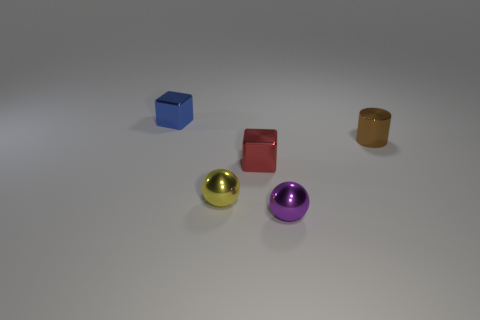There is another shiny thing that is the same shape as the small blue thing; what size is it?
Your answer should be compact. Small. Is there anything else that is the same size as the purple shiny thing?
Give a very brief answer. Yes. What number of things are either metal cubes that are to the right of the blue shiny block or objects behind the red thing?
Your response must be concise. 3. Does the purple ball have the same size as the brown shiny thing?
Your answer should be compact. Yes. Are there more small yellow cylinders than metal things?
Offer a very short reply. No. How many other objects are the same color as the metal cylinder?
Make the answer very short. 0. How many objects are either tiny metal objects or cylinders?
Provide a succinct answer. 5. Does the small brown thing that is right of the blue shiny object have the same shape as the tiny purple metallic object?
Give a very brief answer. No. The tiny metal block to the left of the ball that is left of the red thing is what color?
Your response must be concise. Blue. Is the number of purple spheres less than the number of large red blocks?
Provide a succinct answer. No. 